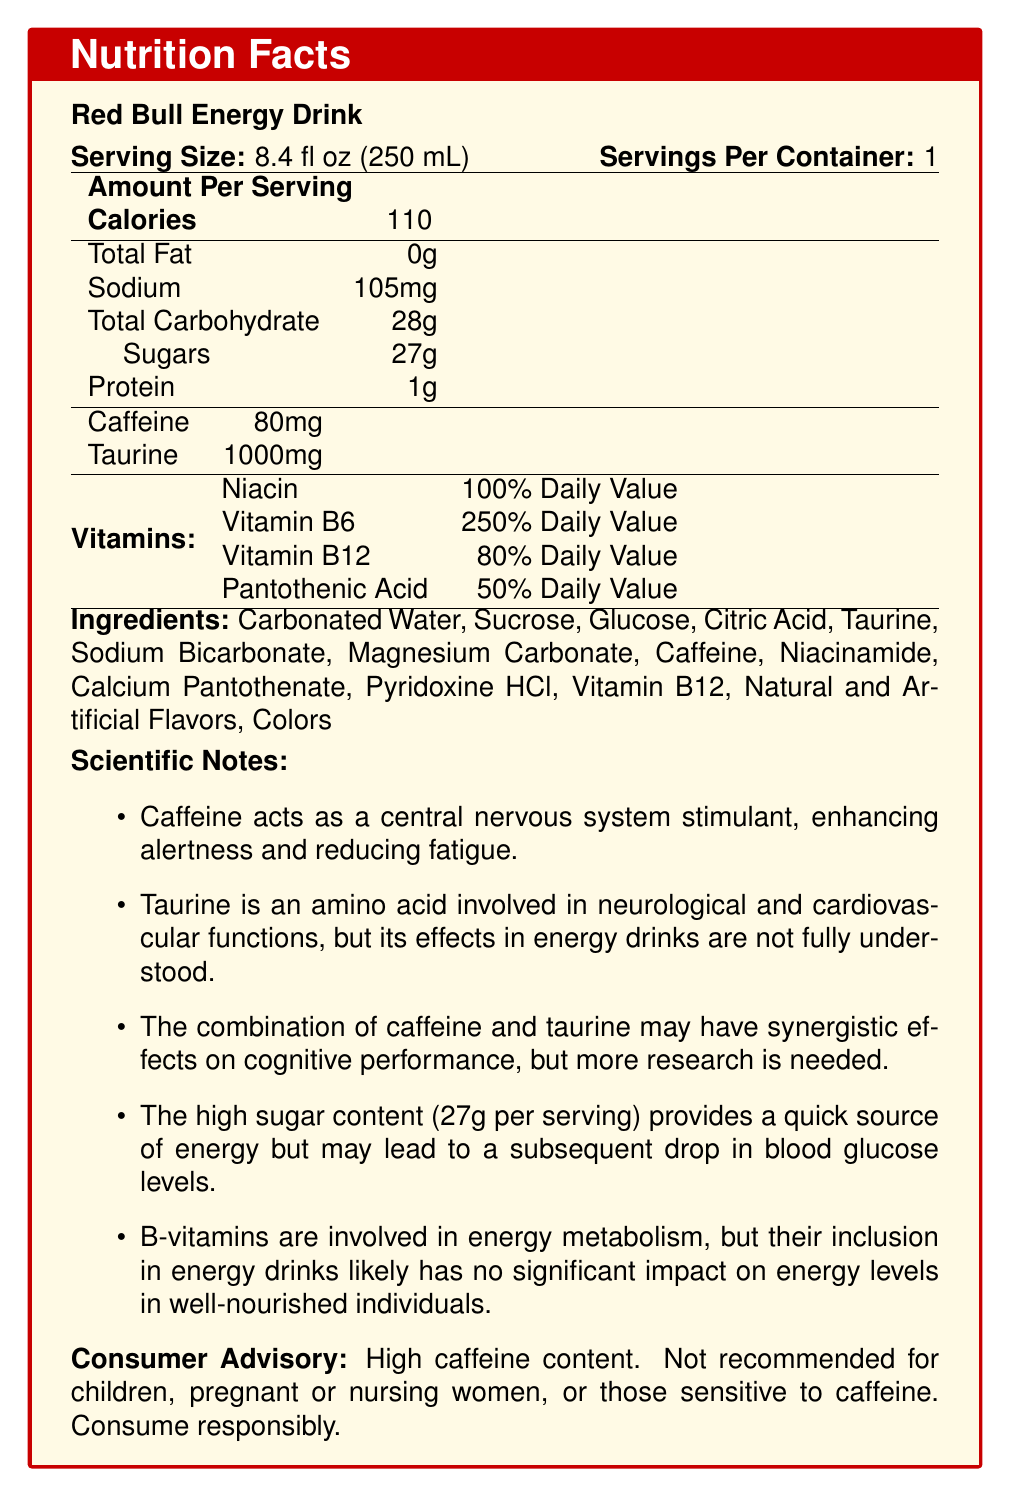What is the serving size of Red Bull Energy Drink? The document specifies that the serving size is 8.4 fl oz (250 mL).
Answer: 8.4 fl oz (250 mL) How much caffeine is in one serving of Red Bull Energy Drink? The document mentions that each serving contains 80 mg of caffeine.
Answer: 80 mg List two main functions of caffeine according to the document. The scientific notes in the document state that caffeine acts as a central nervous system stimulant, enhancing alertness and reducing fatigue.
Answer: Enhancing alertness and reducing fatigue What is the total carbohydrate content per serving? The nutritional facts section outlines that the total carbohydrate content per serving is 28g.
Answer: 28g How much taurine is present in one serving? The document specifies that there is 1000 mg of taurine per serving.
Answer: 1000mg What percentage of the daily value of Vitamin B6 does one serving provide? A. 50% B. 80% C. 100% D. 250% The document states that Vitamin B6 provides 250% of the daily value per serving.
Answer: D. 250% Which ingredient is included in Red Bull for metabolic energy, according to the scientific notes? A. Caffeine B. Taurine C. B-vitamins D. Sugar The scientific notes indicate that B-vitamins are involved in energy metabolism.
Answer: C. B-vitamins Is Red Bull Energy Drink recommended for children or pregnant women? The consumer advisory explicitly states that the product is not recommended for children, pregnant or nursing women.
Answer: No Summarize the main idea of the document. This summary encapsulates the document's emphasis on nutritional data, caffeine and taurine information, scientific insights, and consumer advisories.
Answer: The document provides the nutritional content and ingredients of Red Bull Energy Drink, focusing on its high caffeine and taurine levels, along with scientific notes on their functions. It highlights the quick energy provided by high sugar content and emphasizes a consumer advisory warning about the product’s high caffeine content. How much protein is in one serving? The nutritional facts section lists that one serving contains 1g of protein.
Answer: 1g What is the main reason for including taurine in the energy drink as suggested by the scientific notes? The scientific notes mention that taurine is an amino acid involved in neurological and cardiovascular functions.
Answer: Taurine is involved in neurological and cardiovascular functions. Based on the document, can we determine the exact impact of taurine in energy drinks? The scientific notes state that the effects of taurine in energy drinks are not fully understood, indicating that the exact impact is unclear.
Answer: No Does Red Bull Energy Drink contain sodium? The nutritional facts section mentions that each serving contains 105 mg of sodium.
Answer: Yes According to the document, what could be a downside of the 27g of sugar in Red Bull Energy Drink? The scientific notes indicate that while the high sugar content provides a quick source of energy, it may also result in a subsequent drop in blood glucose levels.
Answer: It may lead to a subsequent drop in blood glucose levels. List three ingredients found in Red Bull Energy Drink besides caffeine and taurine. The ingredients section lists several components, including Carbonated Water, Sucrose, and Glucose, among others.
Answer: Carbonated Water, Sucrose, and Glucose What is one reason the document suggests B-vitamins might not significantly impact energy levels in well-nourished individuals? The scientific notes mention that the inclusion of B-vitamins in energy drinks is likely to have no significant impact on energy levels in well-nourished individuals.
Answer: Well-nourished individuals likely get enough B-vitamins from their regular diet. 